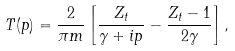<formula> <loc_0><loc_0><loc_500><loc_500>T ( p ) = \frac { 2 } { \pi m } \left [ \frac { Z _ { t } } { \gamma + i p } - \frac { Z _ { t } - 1 } { 2 \gamma } \right ] ,</formula> 